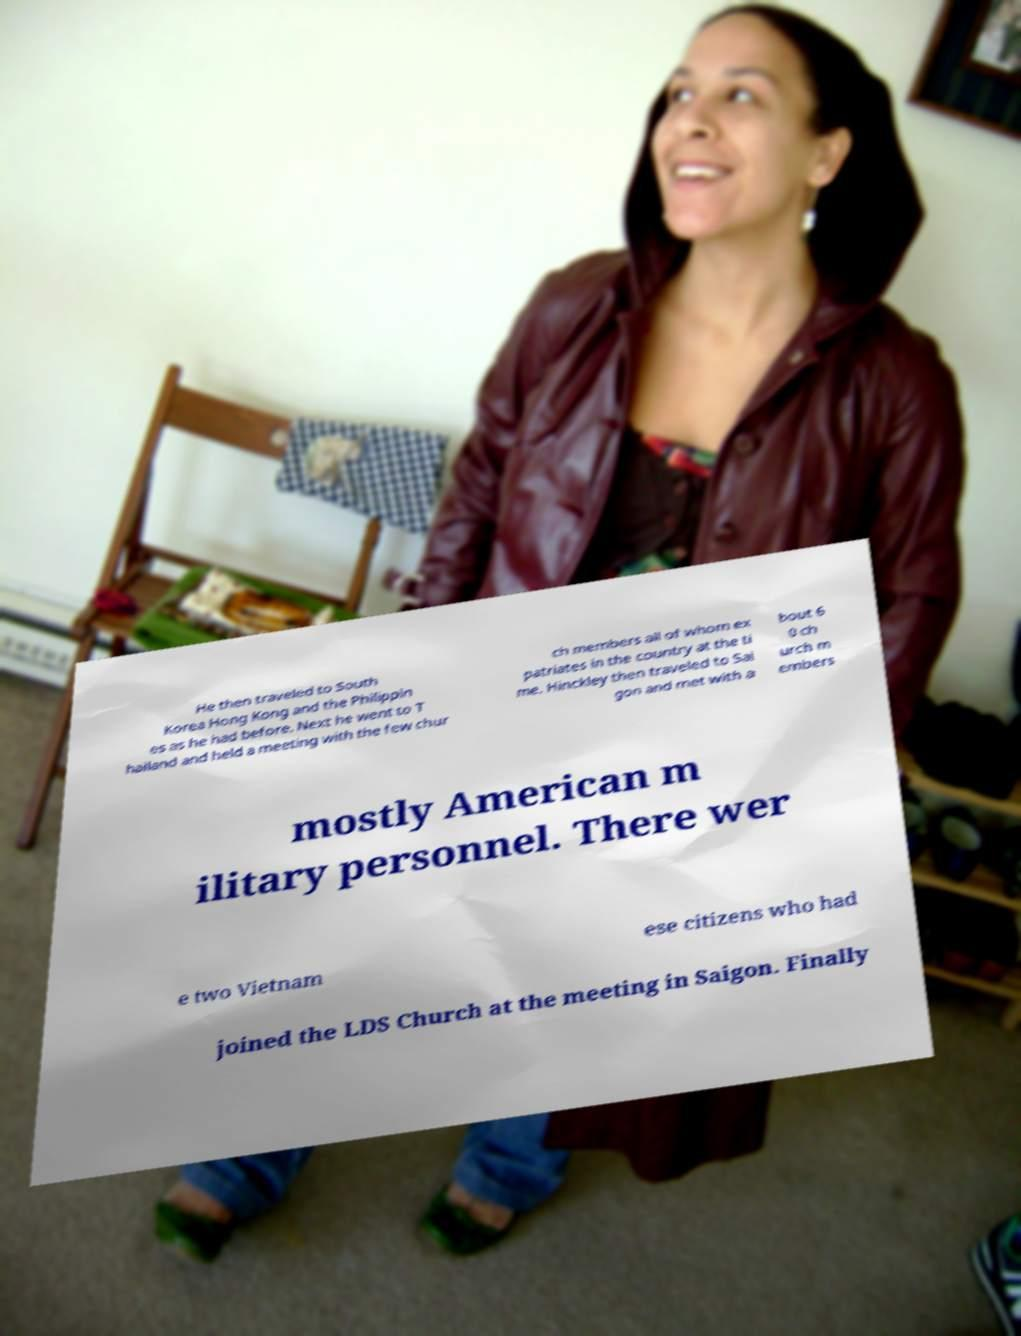There's text embedded in this image that I need extracted. Can you transcribe it verbatim? He then traveled to South Korea Hong Kong and the Philippin es as he had before. Next he went to T hailand and held a meeting with the few chur ch members all of whom ex patriates in the country at the ti me. Hinckley then traveled to Sai gon and met with a bout 6 0 ch urch m embers mostly American m ilitary personnel. There wer e two Vietnam ese citizens who had joined the LDS Church at the meeting in Saigon. Finally 